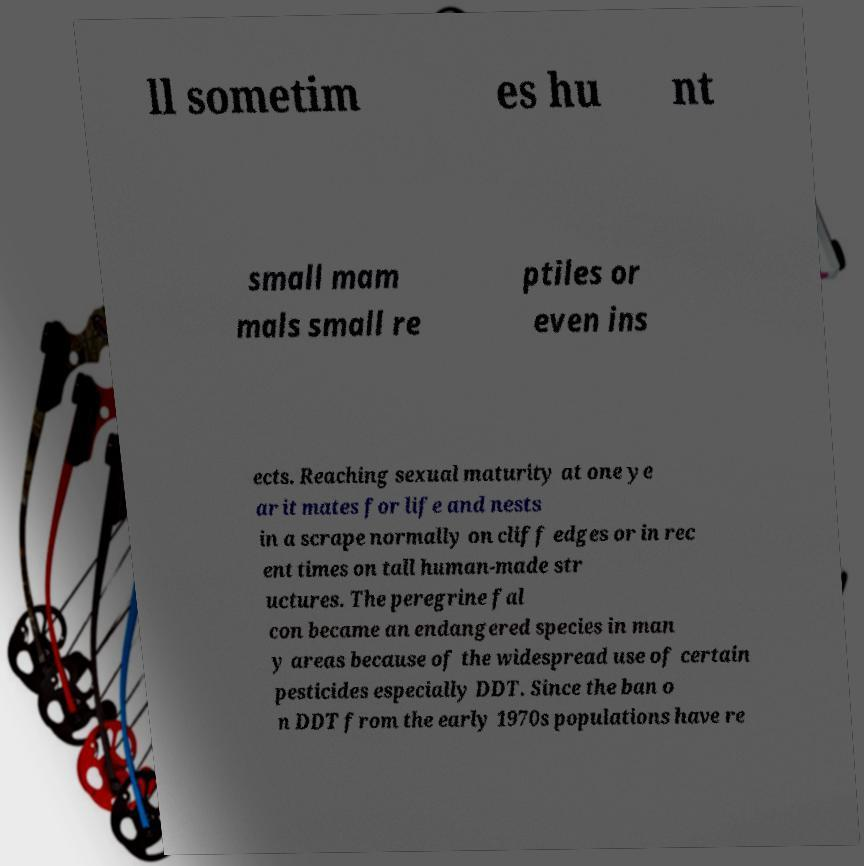Please identify and transcribe the text found in this image. ll sometim es hu nt small mam mals small re ptiles or even ins ects. Reaching sexual maturity at one ye ar it mates for life and nests in a scrape normally on cliff edges or in rec ent times on tall human-made str uctures. The peregrine fal con became an endangered species in man y areas because of the widespread use of certain pesticides especially DDT. Since the ban o n DDT from the early 1970s populations have re 